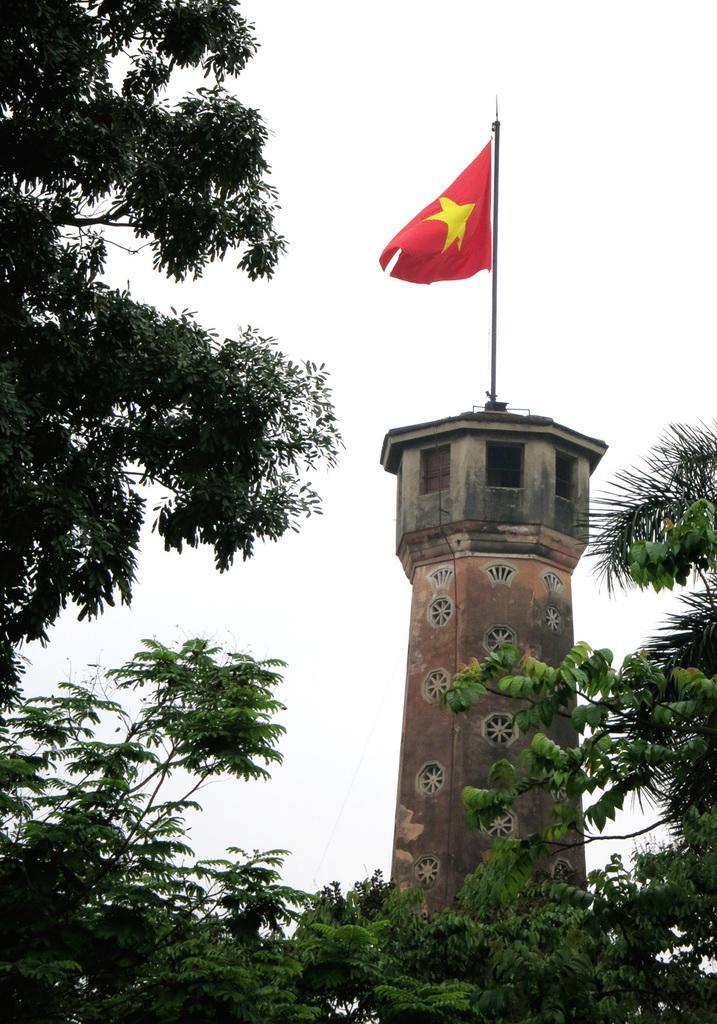Can you describe this image briefly? In this picture there is a flag on the tower. In the foreground there are trees. At the top there is sky. 